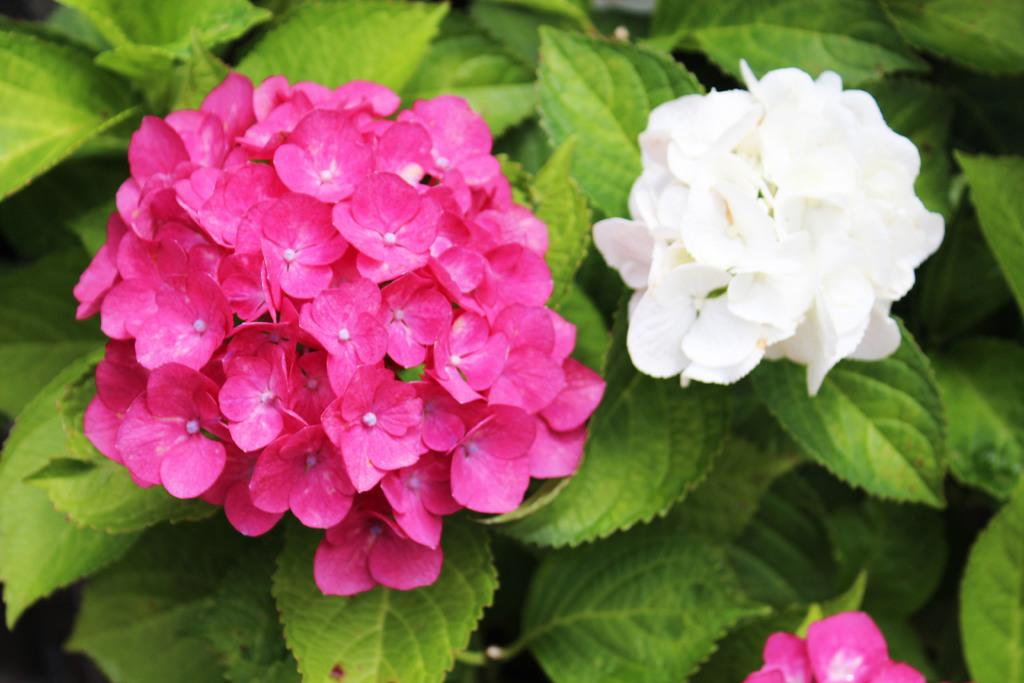What type of plant life can be seen in the image? There are flowers and leaves in the image. Can you describe the flowers in the image? Unfortunately, the facts provided do not give specific details about the flowers. Are there any other elements in the image besides the flowers and leaves? The facts provided do not mention any other elements in the image. How does the distribution of chalk in the image affect the growth of the flowers? There is no chalk present in the image, so its distribution cannot affect the growth of the flowers. 